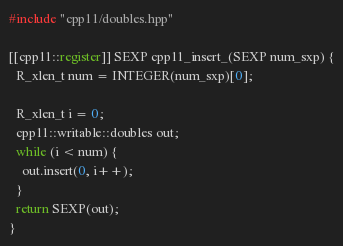<code> <loc_0><loc_0><loc_500><loc_500><_C++_>#include "cpp11/doubles.hpp"

[[cpp11::register]] SEXP cpp11_insert_(SEXP num_sxp) {
  R_xlen_t num = INTEGER(num_sxp)[0];

  R_xlen_t i = 0;
  cpp11::writable::doubles out;
  while (i < num) {
    out.insert(0, i++);
  }
  return SEXP(out);
}
</code> 